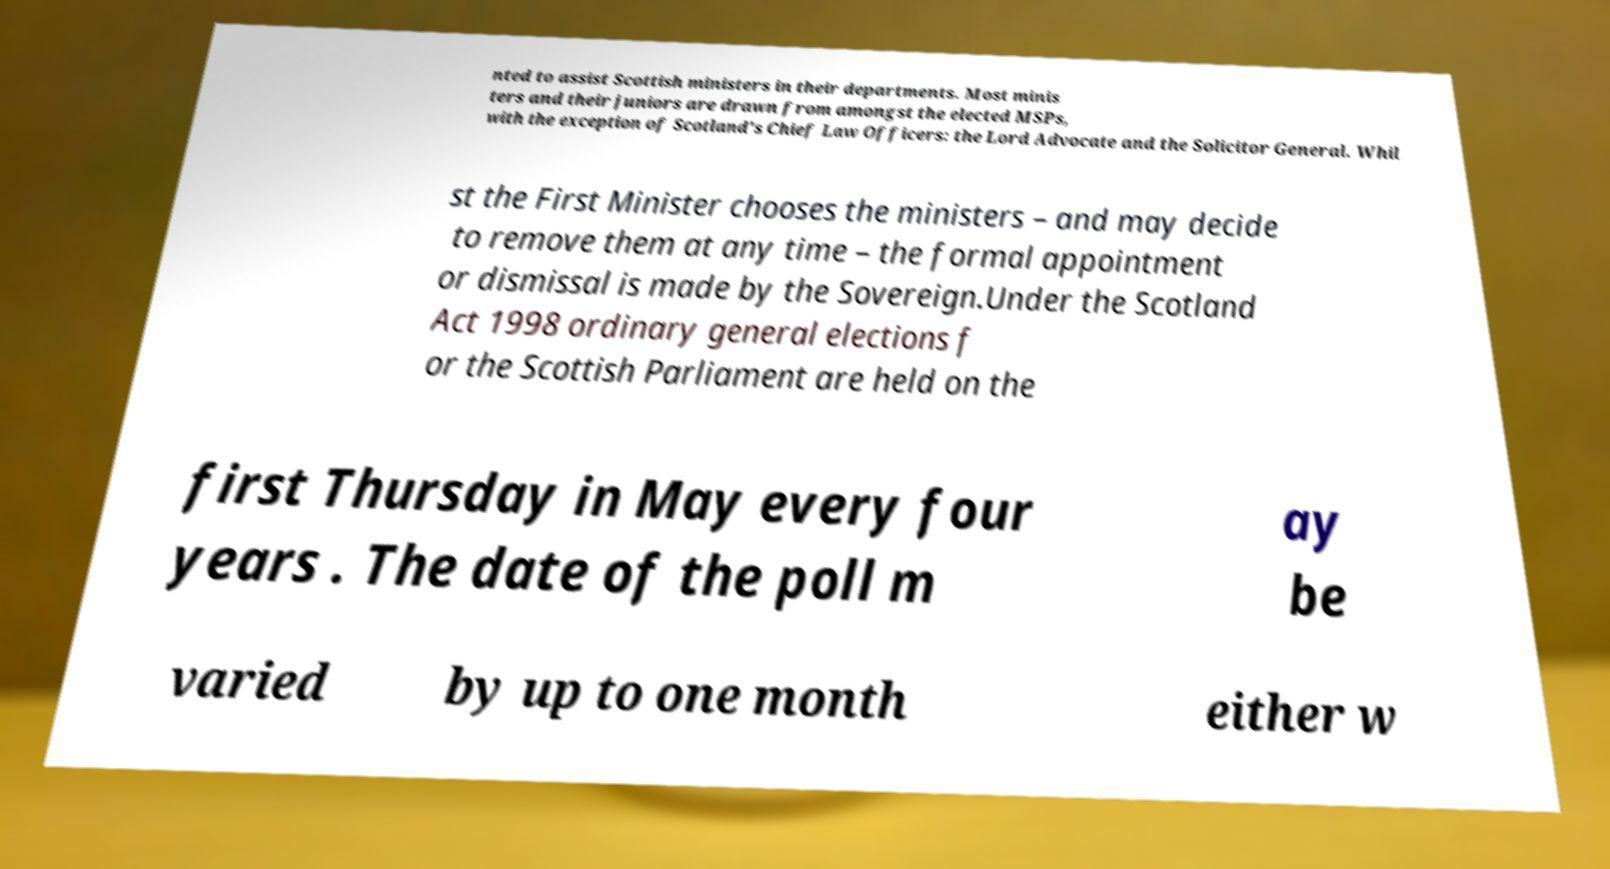Could you extract and type out the text from this image? nted to assist Scottish ministers in their departments. Most minis ters and their juniors are drawn from amongst the elected MSPs, with the exception of Scotland's Chief Law Officers: the Lord Advocate and the Solicitor General. Whil st the First Minister chooses the ministers – and may decide to remove them at any time – the formal appointment or dismissal is made by the Sovereign.Under the Scotland Act 1998 ordinary general elections f or the Scottish Parliament are held on the first Thursday in May every four years . The date of the poll m ay be varied by up to one month either w 